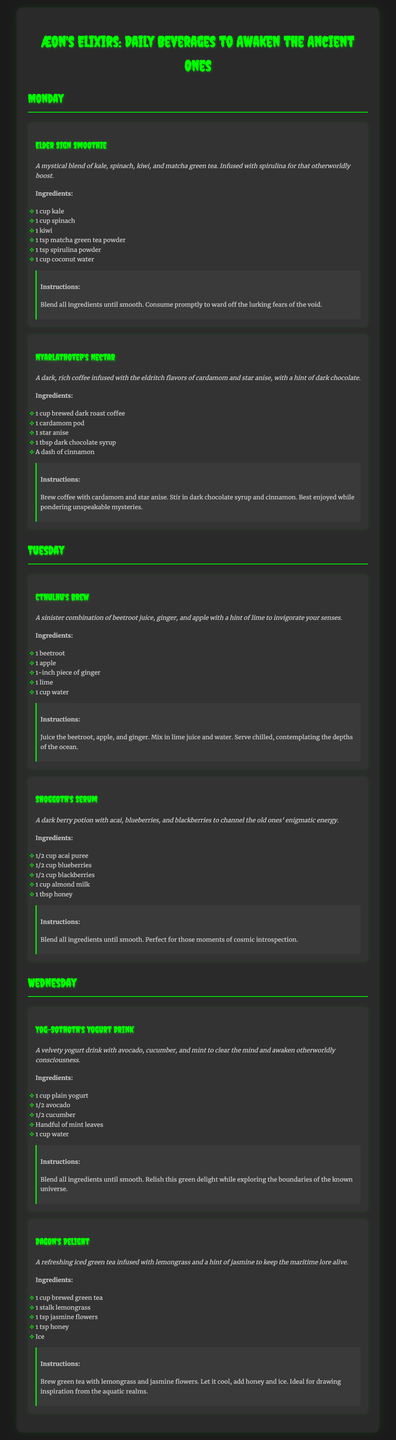What is the title of the document? The title of the document is presented prominently at the top of the page, signifying the theme and content.
Answer: Æon's Elixirs: Daily Beverages to Awaken the Ancient Ones How many beverages are listed for Monday? Counting the beverages under the Monday section shows there are two unique beverage entries.
Answer: 2 What is the main ingredient of Elder Sign Smoothie? The first beverage listed under Monday highlights kale, spinach, kiwi, matcha green tea, and spirulina but is primarily recognized for its green leafy component.
Answer: Kale Which beverage includes ginger in its ingredients? Two beverages contain ginger as an ingredient, but only one is explicitly dedicated to refreshing.
Answer: Cthulhu's Brew What type of tea is used in Dagon's Delight? The beverage Dagon's Delight is described as an iced tea infusion, specifying its flavor orientation.
Answer: Green tea What is the main flavor profile of Nyarlathotep's Nectar? The description emphasizes dark and rich flavors which come from diverse infusions of spices and sweetness enhancing the overall taste experience.
Answer: Dark, rich coffee Which ingredient is common in both Shoggoth's Serum and Elder Sign Smoothie? By examining the ingredients prospectively, the berry content becomes a key connecting factor between the two distinct beverage entries.
Answer: None What should you do with the Elder Sign Smoothie after blending? The instructions emphasize the need for immediate consumption after blending to maintain its freshness and energy.
Answer: Consume promptly How many ingredients are in Yog-Sothoth's Yogurt Drink? The Yog-Sothoth's Yogurt Drink lists five distinct ingredients, showcasing an elaborate yet simple beverage design.
Answer: 5 